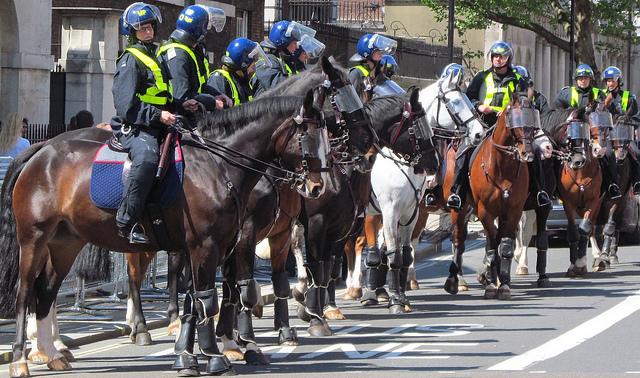Are all of these horses the same color?
Give a very brief answer. No. Are the people busy?
Answer briefly. No. What country is this in?
Write a very short answer. Usa. Where are the horses in the picture?
Give a very brief answer. Street. Are the horses a dark color?
Concise answer only. Yes. Are these cows?
Write a very short answer. No. How many people are riding?
Keep it brief. 12. What are the people doing on the horses?
Answer briefly. Sitting. What type event is this?
Be succinct. Parade. 